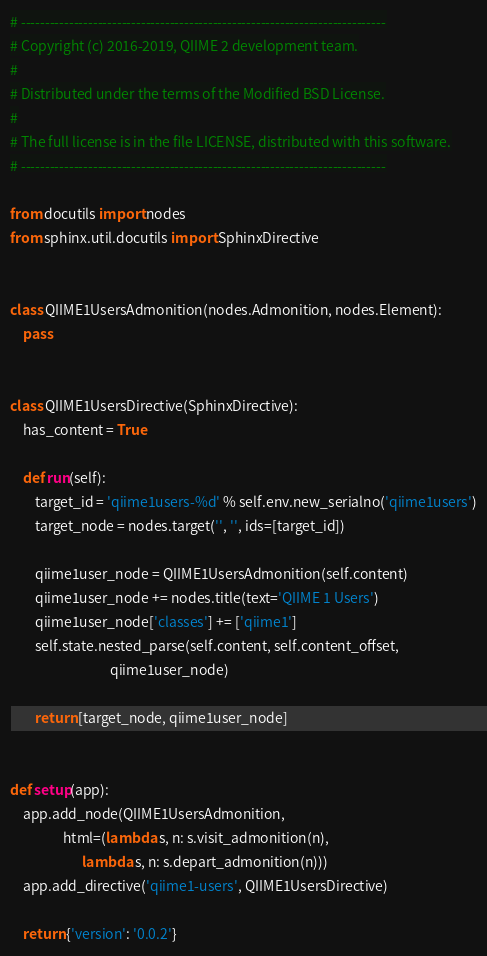<code> <loc_0><loc_0><loc_500><loc_500><_Python_># ----------------------------------------------------------------------------
# Copyright (c) 2016-2019, QIIME 2 development team.
#
# Distributed under the terms of the Modified BSD License.
#
# The full license is in the file LICENSE, distributed with this software.
# ----------------------------------------------------------------------------

from docutils import nodes
from sphinx.util.docutils import SphinxDirective


class QIIME1UsersAdmonition(nodes.Admonition, nodes.Element):
    pass


class QIIME1UsersDirective(SphinxDirective):
    has_content = True

    def run(self):
        target_id = 'qiime1users-%d' % self.env.new_serialno('qiime1users')
        target_node = nodes.target('', '', ids=[target_id])

        qiime1user_node = QIIME1UsersAdmonition(self.content)
        qiime1user_node += nodes.title(text='QIIME 1 Users')
        qiime1user_node['classes'] += ['qiime1']
        self.state.nested_parse(self.content, self.content_offset,
                                qiime1user_node)

        return [target_node, qiime1user_node]


def setup(app):
    app.add_node(QIIME1UsersAdmonition,
                 html=(lambda s, n: s.visit_admonition(n),
                       lambda s, n: s.depart_admonition(n)))
    app.add_directive('qiime1-users', QIIME1UsersDirective)

    return {'version': '0.0.2'}
</code> 